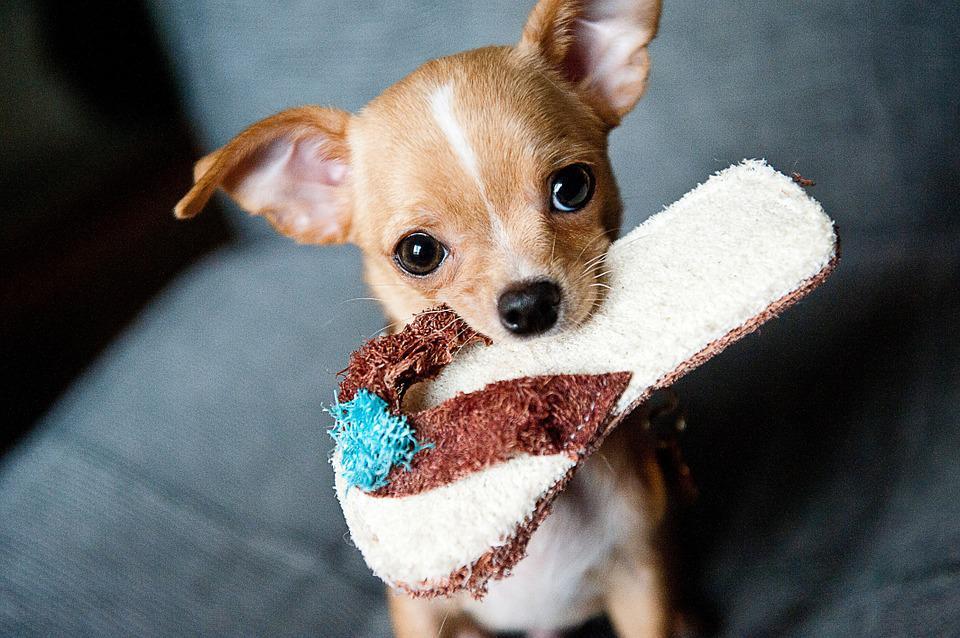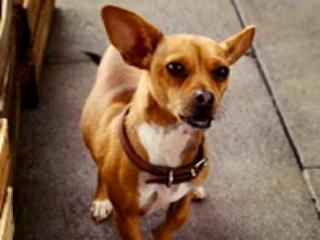The first image is the image on the left, the second image is the image on the right. For the images shown, is this caption "The dog in the image on the left is baring its teeth." true? Answer yes or no. No. The first image is the image on the left, the second image is the image on the right. Examine the images to the left and right. Is the description "There is only one dog baring its teeth, in total." accurate? Answer yes or no. No. 